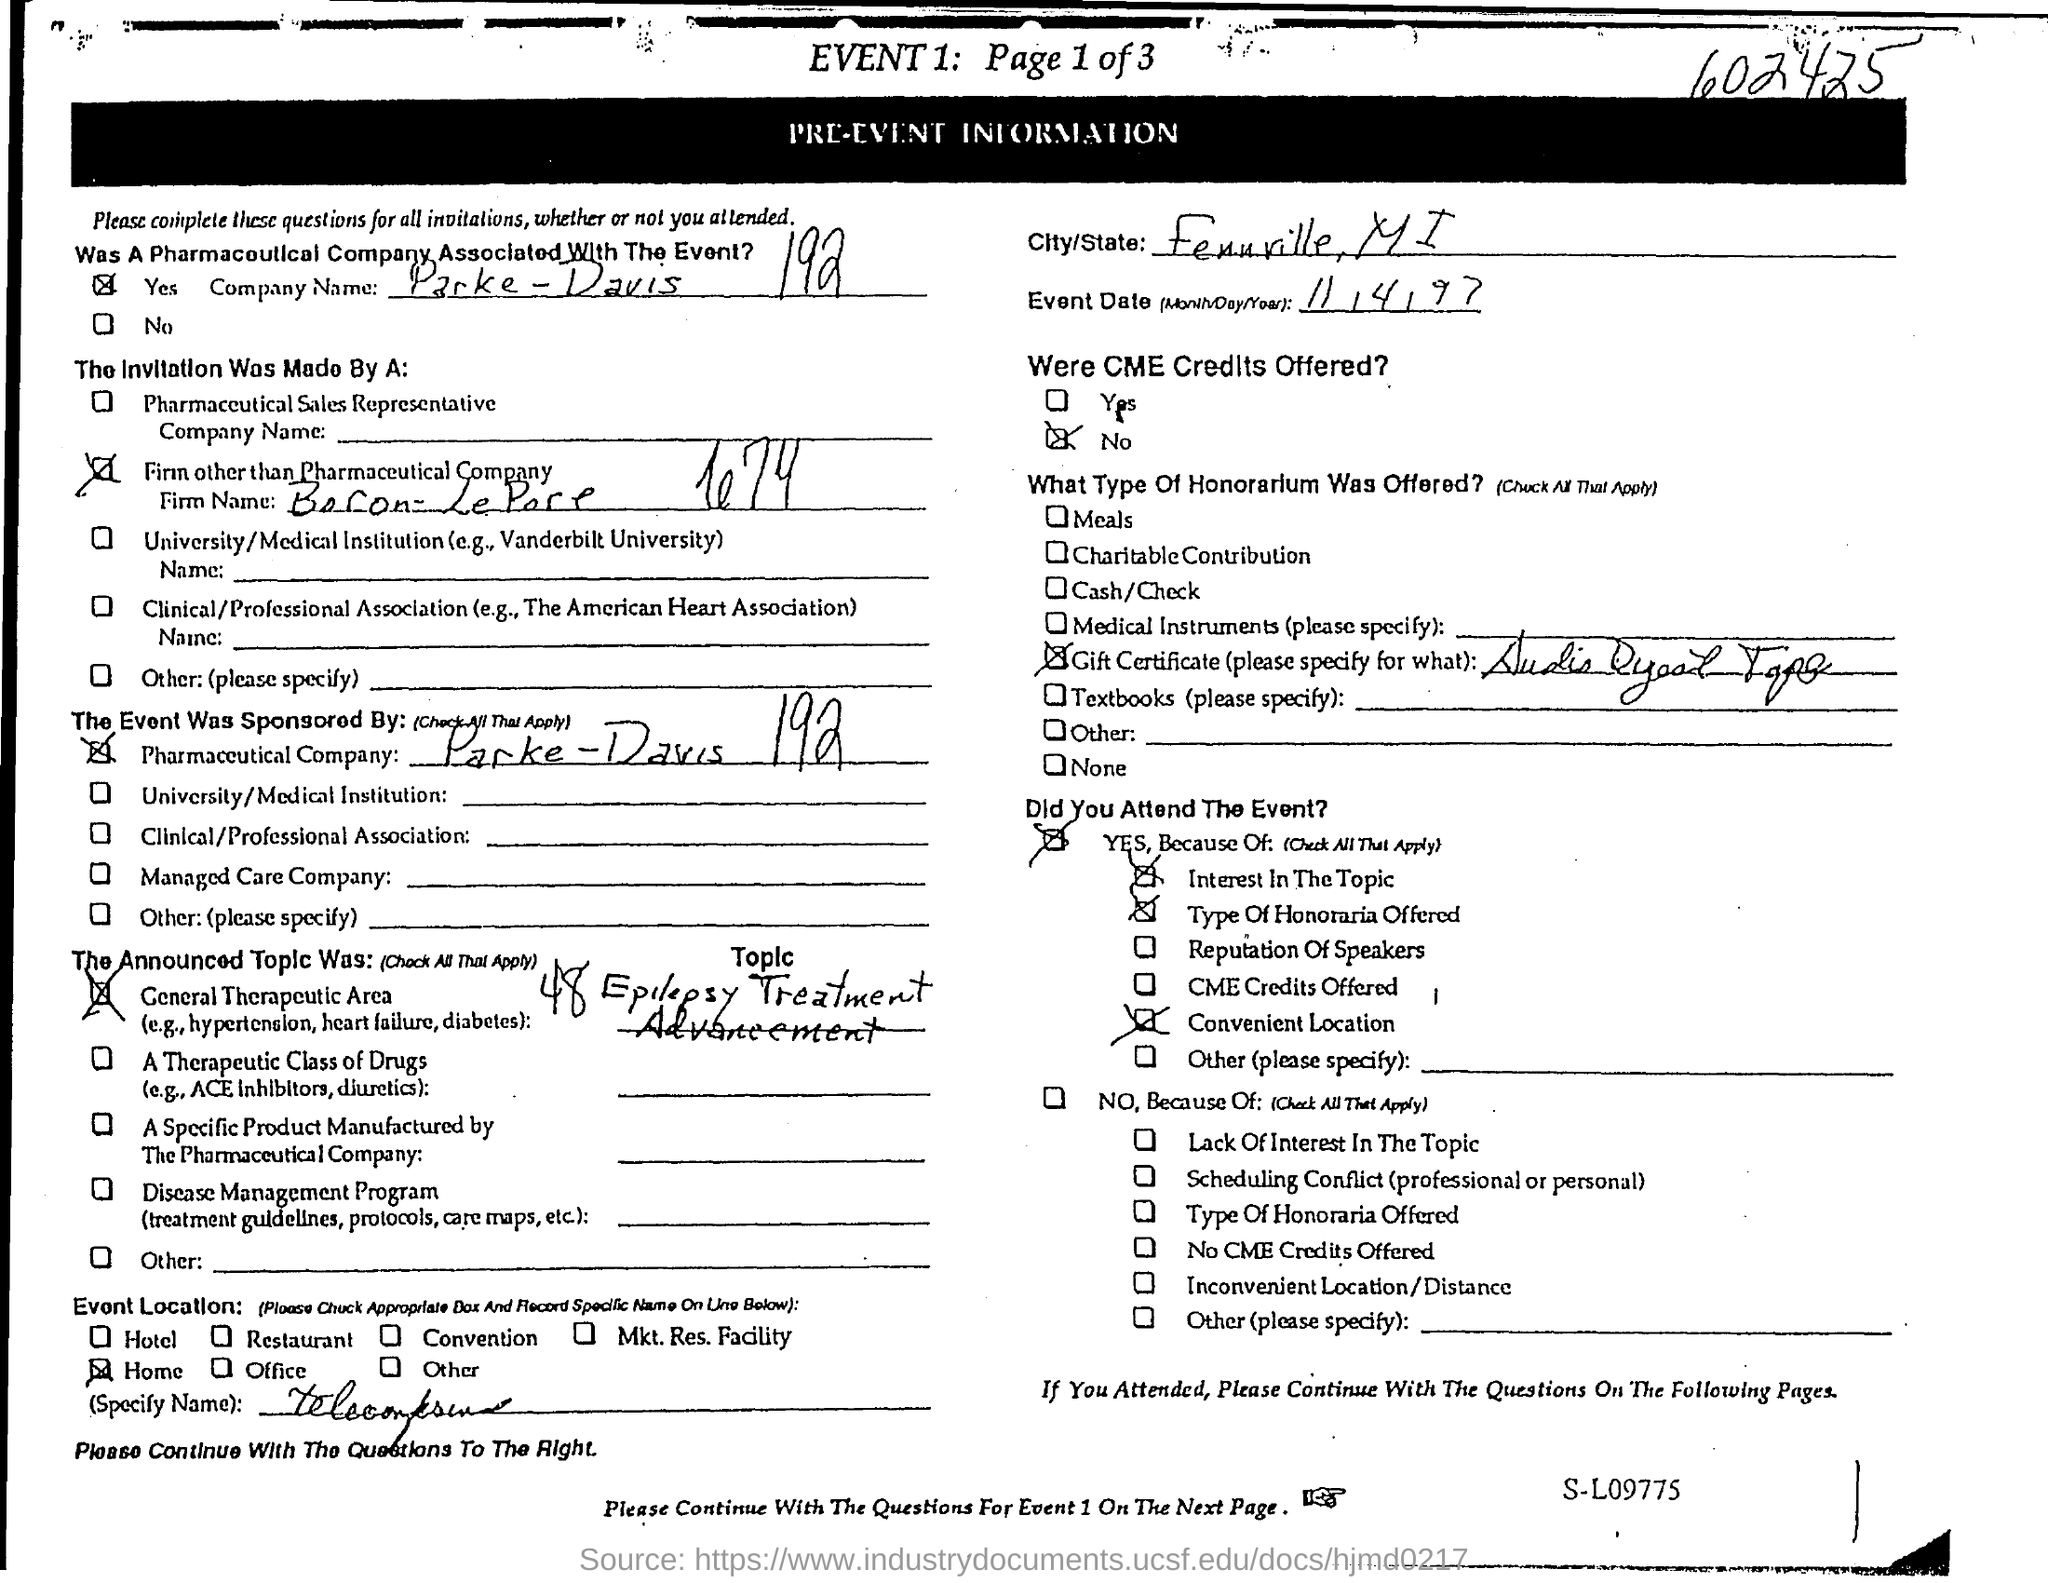What is the number mentioned at the top right corner?
Your answer should be compact. 602425. What is the pharmaceuticals company name?
Ensure brevity in your answer.  Parke-Davis 192. What is th event date?
Your response must be concise. 11/4/97. Were cme credits offered?
Ensure brevity in your answer.  No. 